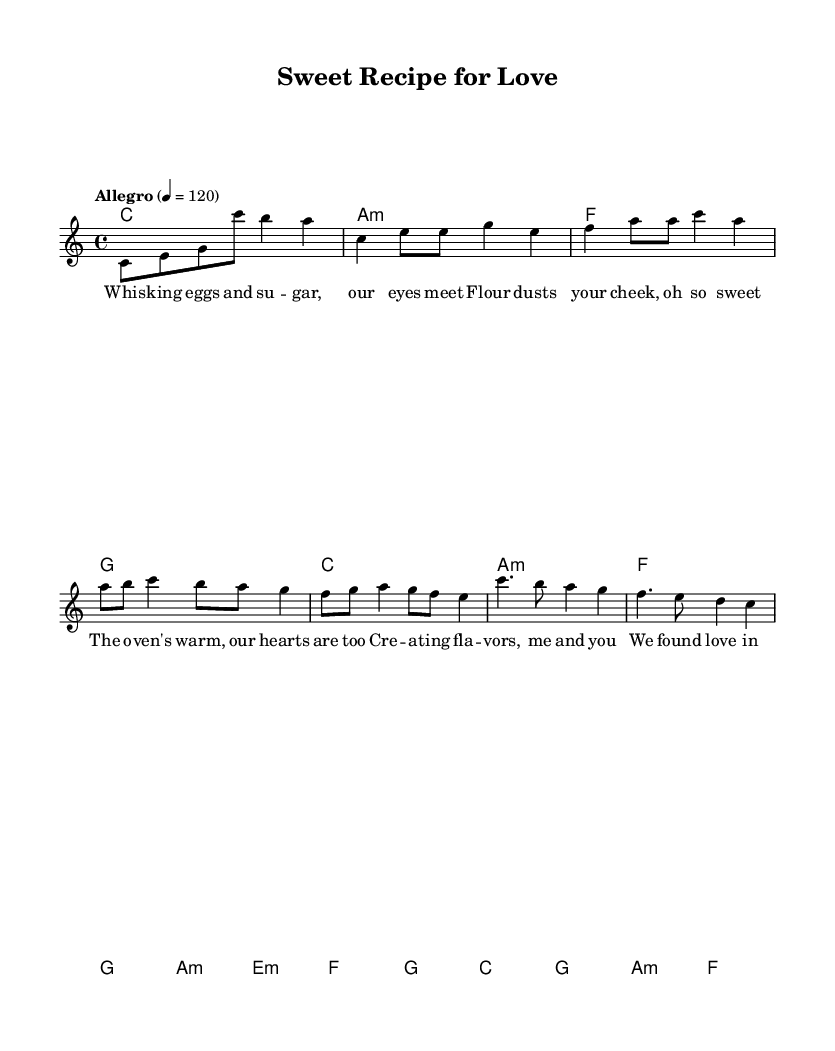What is the key signature of this music? The key signature is indicated at the beginning of the piece, which is C major, as there are no sharps or flats shown.
Answer: C major What is the time signature of this music? The time signature is shown at the beginning, which is 4/4, meaning there are four beats in each measure and a quarter note receives one beat.
Answer: 4/4 What is the tempo marking for this piece? The tempo marking is provided in the header section, indicating that the music should be played at a speed of Allegro, specifically 120 beats per minute.
Answer: 120 How many sections does the song have? By examining the structure of the music, it can be identified that there are four distinct sections: Intro, Verse, Pre-Chorus, and Chorus.
Answer: Four What mood does the lyrics convey throughout the song? The lyrics express a romantic and joyful mood as they describe love found through shared culinary experiences, enhancing the overall sentimental theme of the piece.
Answer: Romantic Which chords are used in the chorus? The chords during the chorus section, as shown in the harmonies, are C, G, A minor, and F, providing a harmonious backing to the melody.
Answer: C, G, A minor, F What does the phrase "Shared passion, it's our mission" suggest? This phrase indicates a strong connection and shared enthusiasm in cooking together, which is a central theme of the song, emphasizing collaboration and love.
Answer: Shared connection 